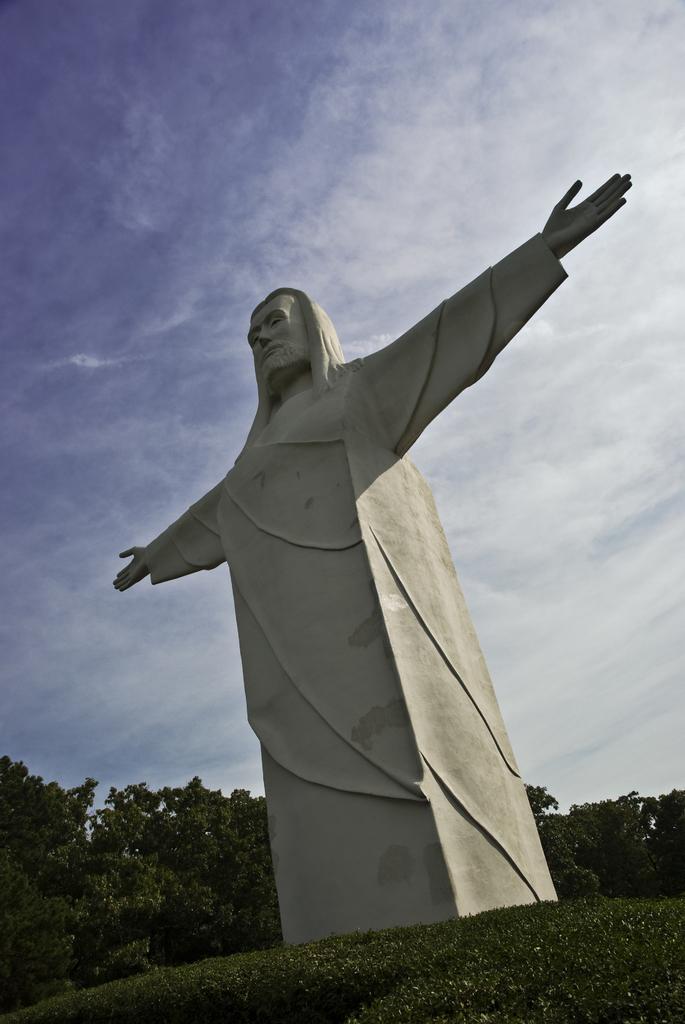In one or two sentences, can you explain what this image depicts? In this picture we can see a statue in the front, at the bottom there is grass, we can see trees in the background, there is the sky at the top of the picture. 